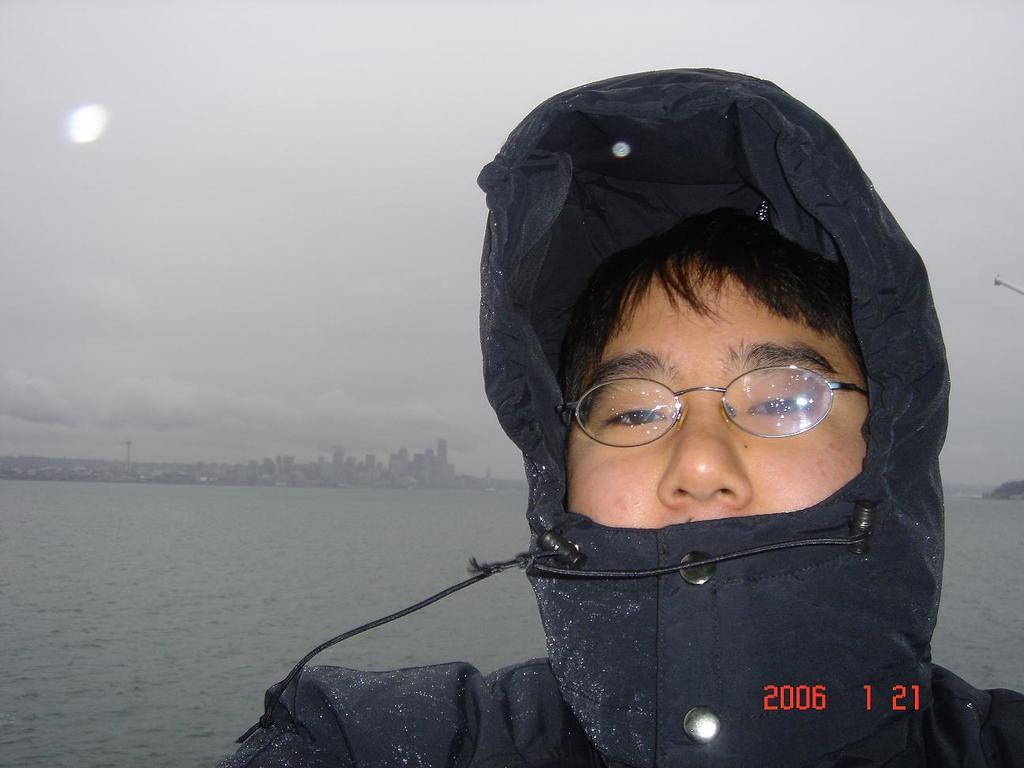What is the person in the image wearing? The person in the image is wearing a black dress. What can be seen in the background of the image? Buildings and water are visible in the background of the image. What is the condition of the sky in the image? The sky is cloudy in the image. Can you see a pig or a scarecrow in the image? No, there is no pig or scarecrow present in the image. 